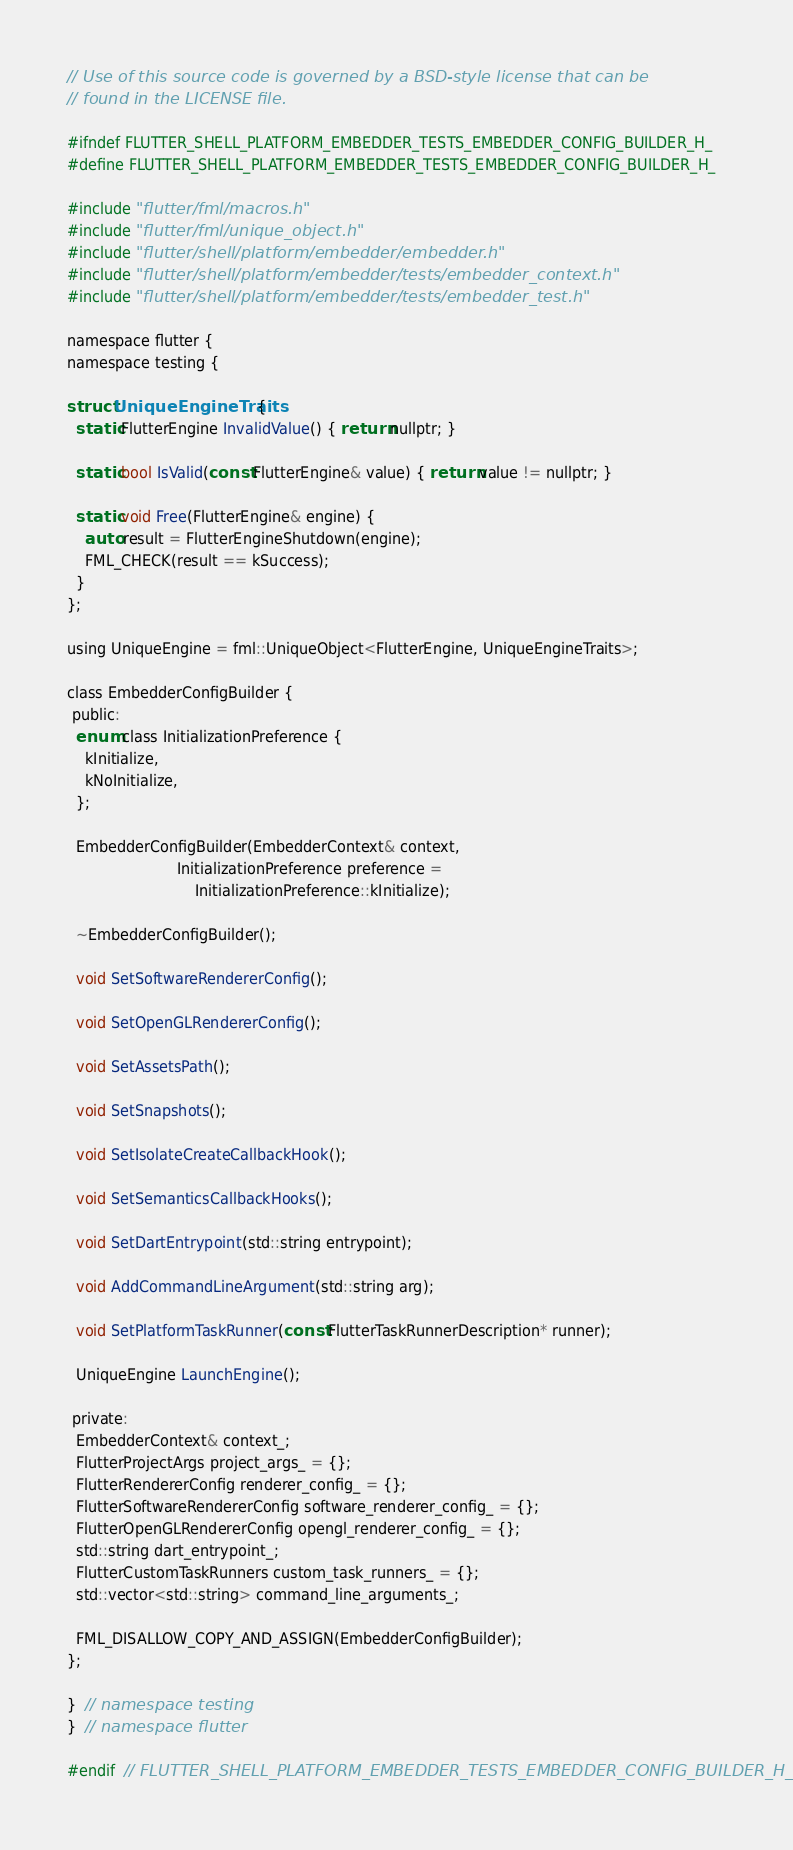<code> <loc_0><loc_0><loc_500><loc_500><_C_>// Use of this source code is governed by a BSD-style license that can be
// found in the LICENSE file.

#ifndef FLUTTER_SHELL_PLATFORM_EMBEDDER_TESTS_EMBEDDER_CONFIG_BUILDER_H_
#define FLUTTER_SHELL_PLATFORM_EMBEDDER_TESTS_EMBEDDER_CONFIG_BUILDER_H_

#include "flutter/fml/macros.h"
#include "flutter/fml/unique_object.h"
#include "flutter/shell/platform/embedder/embedder.h"
#include "flutter/shell/platform/embedder/tests/embedder_context.h"
#include "flutter/shell/platform/embedder/tests/embedder_test.h"

namespace flutter {
namespace testing {

struct UniqueEngineTraits {
  static FlutterEngine InvalidValue() { return nullptr; }

  static bool IsValid(const FlutterEngine& value) { return value != nullptr; }

  static void Free(FlutterEngine& engine) {
    auto result = FlutterEngineShutdown(engine);
    FML_CHECK(result == kSuccess);
  }
};

using UniqueEngine = fml::UniqueObject<FlutterEngine, UniqueEngineTraits>;

class EmbedderConfigBuilder {
 public:
  enum class InitializationPreference {
    kInitialize,
    kNoInitialize,
  };

  EmbedderConfigBuilder(EmbedderContext& context,
                        InitializationPreference preference =
                            InitializationPreference::kInitialize);

  ~EmbedderConfigBuilder();

  void SetSoftwareRendererConfig();

  void SetOpenGLRendererConfig();

  void SetAssetsPath();

  void SetSnapshots();

  void SetIsolateCreateCallbackHook();

  void SetSemanticsCallbackHooks();

  void SetDartEntrypoint(std::string entrypoint);

  void AddCommandLineArgument(std::string arg);

  void SetPlatformTaskRunner(const FlutterTaskRunnerDescription* runner);

  UniqueEngine LaunchEngine();

 private:
  EmbedderContext& context_;
  FlutterProjectArgs project_args_ = {};
  FlutterRendererConfig renderer_config_ = {};
  FlutterSoftwareRendererConfig software_renderer_config_ = {};
  FlutterOpenGLRendererConfig opengl_renderer_config_ = {};
  std::string dart_entrypoint_;
  FlutterCustomTaskRunners custom_task_runners_ = {};
  std::vector<std::string> command_line_arguments_;

  FML_DISALLOW_COPY_AND_ASSIGN(EmbedderConfigBuilder);
};

}  // namespace testing
}  // namespace flutter

#endif  // FLUTTER_SHELL_PLATFORM_EMBEDDER_TESTS_EMBEDDER_CONFIG_BUILDER_H_
</code> 